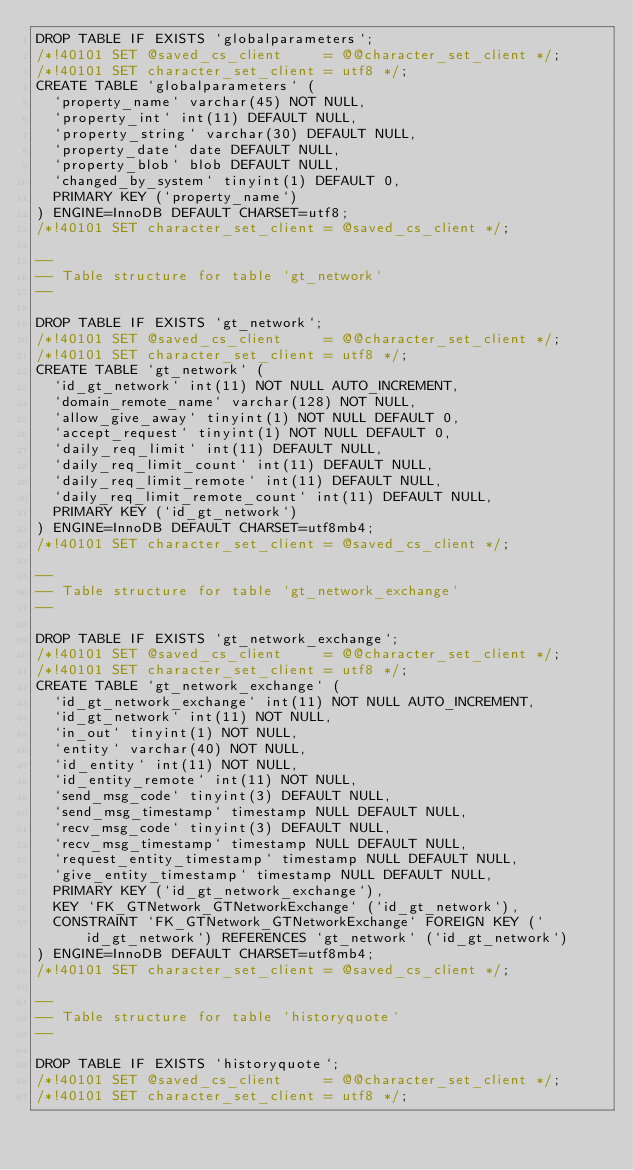Convert code to text. <code><loc_0><loc_0><loc_500><loc_500><_SQL_>DROP TABLE IF EXISTS `globalparameters`;
/*!40101 SET @saved_cs_client     = @@character_set_client */;
/*!40101 SET character_set_client = utf8 */;
CREATE TABLE `globalparameters` (
  `property_name` varchar(45) NOT NULL,
  `property_int` int(11) DEFAULT NULL,
  `property_string` varchar(30) DEFAULT NULL,
  `property_date` date DEFAULT NULL,
  `property_blob` blob DEFAULT NULL,
  `changed_by_system` tinyint(1) DEFAULT 0,
  PRIMARY KEY (`property_name`)
) ENGINE=InnoDB DEFAULT CHARSET=utf8;
/*!40101 SET character_set_client = @saved_cs_client */;

--
-- Table structure for table `gt_network`
--

DROP TABLE IF EXISTS `gt_network`;
/*!40101 SET @saved_cs_client     = @@character_set_client */;
/*!40101 SET character_set_client = utf8 */;
CREATE TABLE `gt_network` (
  `id_gt_network` int(11) NOT NULL AUTO_INCREMENT,
  `domain_remote_name` varchar(128) NOT NULL,
  `allow_give_away` tinyint(1) NOT NULL DEFAULT 0,
  `accept_request` tinyint(1) NOT NULL DEFAULT 0,
  `daily_req_limit` int(11) DEFAULT NULL,
  `daily_req_limit_count` int(11) DEFAULT NULL,
  `daily_req_limit_remote` int(11) DEFAULT NULL,
  `daily_req_limit_remote_count` int(11) DEFAULT NULL,
  PRIMARY KEY (`id_gt_network`)
) ENGINE=InnoDB DEFAULT CHARSET=utf8mb4;
/*!40101 SET character_set_client = @saved_cs_client */;

--
-- Table structure for table `gt_network_exchange`
--

DROP TABLE IF EXISTS `gt_network_exchange`;
/*!40101 SET @saved_cs_client     = @@character_set_client */;
/*!40101 SET character_set_client = utf8 */;
CREATE TABLE `gt_network_exchange` (
  `id_gt_network_exchange` int(11) NOT NULL AUTO_INCREMENT,
  `id_gt_network` int(11) NOT NULL,
  `in_out` tinyint(1) NOT NULL,
  `entity` varchar(40) NOT NULL,
  `id_entity` int(11) NOT NULL,
  `id_entity_remote` int(11) NOT NULL,
  `send_msg_code` tinyint(3) DEFAULT NULL,
  `send_msg_timestamp` timestamp NULL DEFAULT NULL,
  `recv_msg_code` tinyint(3) DEFAULT NULL,
  `recv_msg_timestamp` timestamp NULL DEFAULT NULL,
  `request_entity_timestamp` timestamp NULL DEFAULT NULL,
  `give_entity_timestamp` timestamp NULL DEFAULT NULL,
  PRIMARY KEY (`id_gt_network_exchange`),
  KEY `FK_GTNetwork_GTNetworkExchange` (`id_gt_network`),
  CONSTRAINT `FK_GTNetwork_GTNetworkExchange` FOREIGN KEY (`id_gt_network`) REFERENCES `gt_network` (`id_gt_network`)
) ENGINE=InnoDB DEFAULT CHARSET=utf8mb4;
/*!40101 SET character_set_client = @saved_cs_client */;

--
-- Table structure for table `historyquote`
--

DROP TABLE IF EXISTS `historyquote`;
/*!40101 SET @saved_cs_client     = @@character_set_client */;
/*!40101 SET character_set_client = utf8 */;</code> 